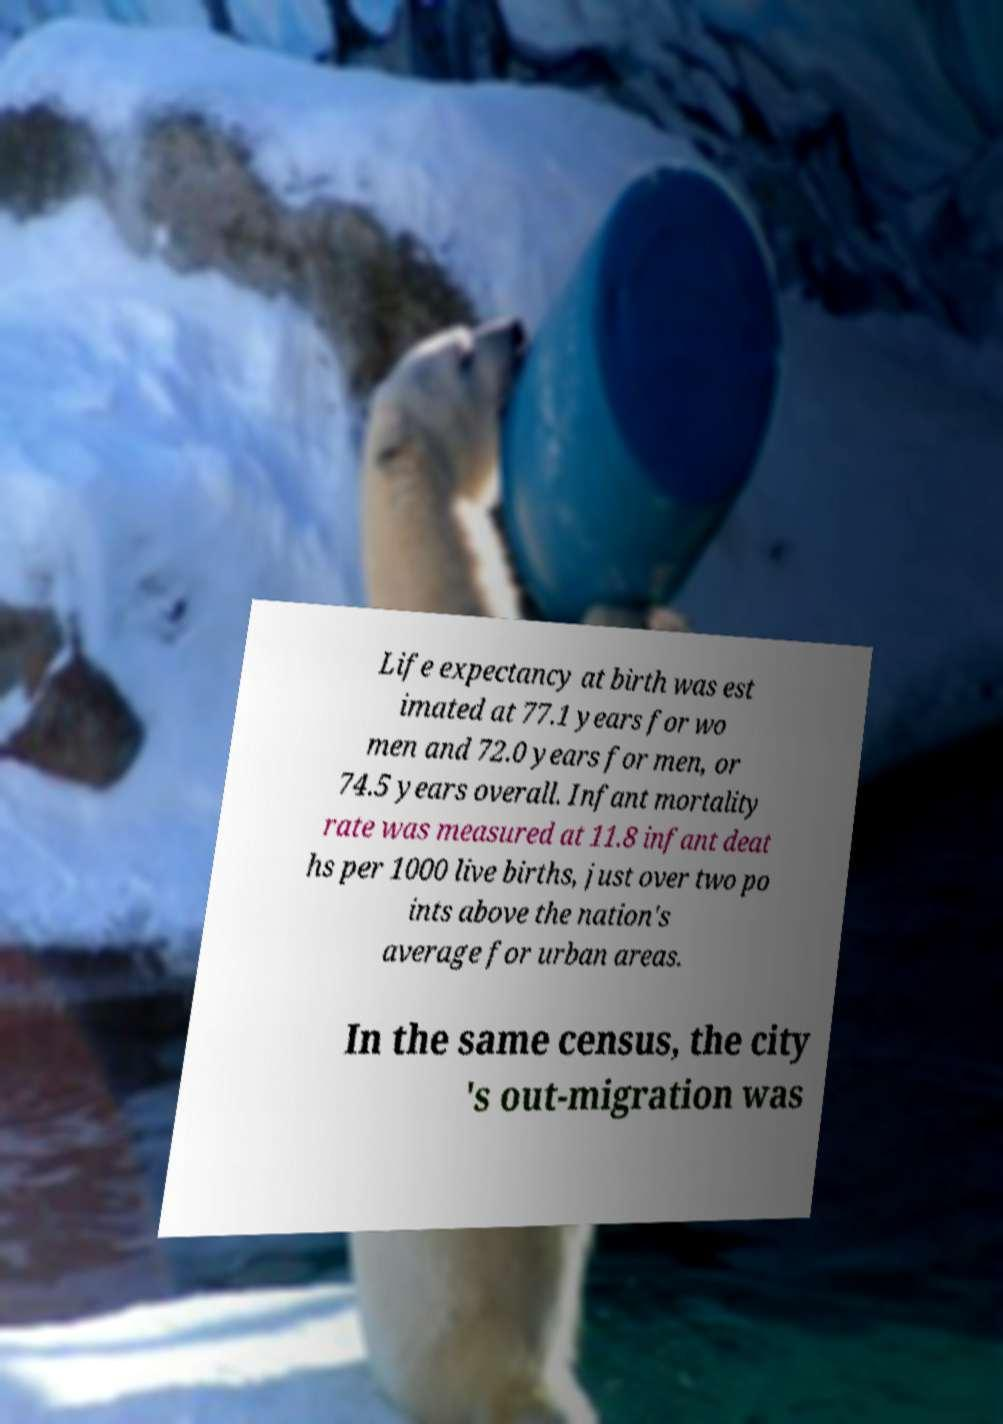Please read and relay the text visible in this image. What does it say? Life expectancy at birth was est imated at 77.1 years for wo men and 72.0 years for men, or 74.5 years overall. Infant mortality rate was measured at 11.8 infant deat hs per 1000 live births, just over two po ints above the nation's average for urban areas. In the same census, the city 's out-migration was 